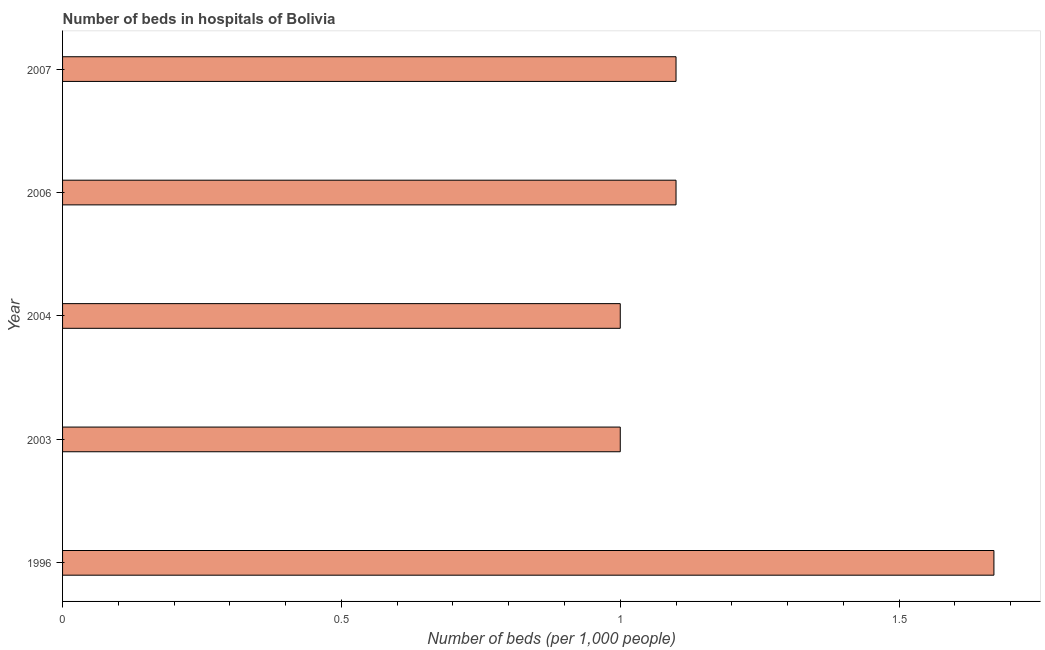Does the graph contain any zero values?
Your answer should be very brief. No. Does the graph contain grids?
Give a very brief answer. No. What is the title of the graph?
Your response must be concise. Number of beds in hospitals of Bolivia. What is the label or title of the X-axis?
Keep it short and to the point. Number of beds (per 1,0 people). What is the label or title of the Y-axis?
Ensure brevity in your answer.  Year. Across all years, what is the maximum number of hospital beds?
Make the answer very short. 1.67. What is the sum of the number of hospital beds?
Make the answer very short. 5.87. What is the average number of hospital beds per year?
Provide a short and direct response. 1.17. What is the median number of hospital beds?
Provide a short and direct response. 1.1. In how many years, is the number of hospital beds greater than 1.5 %?
Your answer should be very brief. 1. Do a majority of the years between 2003 and 2007 (inclusive) have number of hospital beds greater than 0.4 %?
Your response must be concise. Yes. What is the ratio of the number of hospital beds in 2004 to that in 2007?
Provide a short and direct response. 0.91. Is the number of hospital beds in 2004 less than that in 2006?
Keep it short and to the point. Yes. Is the difference between the number of hospital beds in 2003 and 2004 greater than the difference between any two years?
Provide a succinct answer. No. What is the difference between the highest and the second highest number of hospital beds?
Your answer should be compact. 0.57. Is the sum of the number of hospital beds in 1996 and 2006 greater than the maximum number of hospital beds across all years?
Offer a very short reply. Yes. What is the difference between the highest and the lowest number of hospital beds?
Offer a terse response. 0.67. What is the difference between two consecutive major ticks on the X-axis?
Your answer should be compact. 0.5. Are the values on the major ticks of X-axis written in scientific E-notation?
Give a very brief answer. No. What is the Number of beds (per 1,000 people) in 1996?
Make the answer very short. 1.67. What is the Number of beds (per 1,000 people) of 2003?
Offer a very short reply. 1. What is the Number of beds (per 1,000 people) of 2004?
Make the answer very short. 1. What is the Number of beds (per 1,000 people) in 2006?
Provide a succinct answer. 1.1. What is the Number of beds (per 1,000 people) in 2007?
Give a very brief answer. 1.1. What is the difference between the Number of beds (per 1,000 people) in 1996 and 2003?
Provide a succinct answer. 0.67. What is the difference between the Number of beds (per 1,000 people) in 1996 and 2004?
Keep it short and to the point. 0.67. What is the difference between the Number of beds (per 1,000 people) in 1996 and 2006?
Provide a short and direct response. 0.57. What is the difference between the Number of beds (per 1,000 people) in 1996 and 2007?
Give a very brief answer. 0.57. What is the difference between the Number of beds (per 1,000 people) in 2003 and 2007?
Ensure brevity in your answer.  -0.1. What is the difference between the Number of beds (per 1,000 people) in 2004 and 2007?
Offer a very short reply. -0.1. What is the difference between the Number of beds (per 1,000 people) in 2006 and 2007?
Make the answer very short. 0. What is the ratio of the Number of beds (per 1,000 people) in 1996 to that in 2003?
Ensure brevity in your answer.  1.67. What is the ratio of the Number of beds (per 1,000 people) in 1996 to that in 2004?
Offer a very short reply. 1.67. What is the ratio of the Number of beds (per 1,000 people) in 1996 to that in 2006?
Give a very brief answer. 1.52. What is the ratio of the Number of beds (per 1,000 people) in 1996 to that in 2007?
Keep it short and to the point. 1.52. What is the ratio of the Number of beds (per 1,000 people) in 2003 to that in 2006?
Your answer should be very brief. 0.91. What is the ratio of the Number of beds (per 1,000 people) in 2003 to that in 2007?
Your answer should be very brief. 0.91. What is the ratio of the Number of beds (per 1,000 people) in 2004 to that in 2006?
Your response must be concise. 0.91. What is the ratio of the Number of beds (per 1,000 people) in 2004 to that in 2007?
Provide a succinct answer. 0.91. 